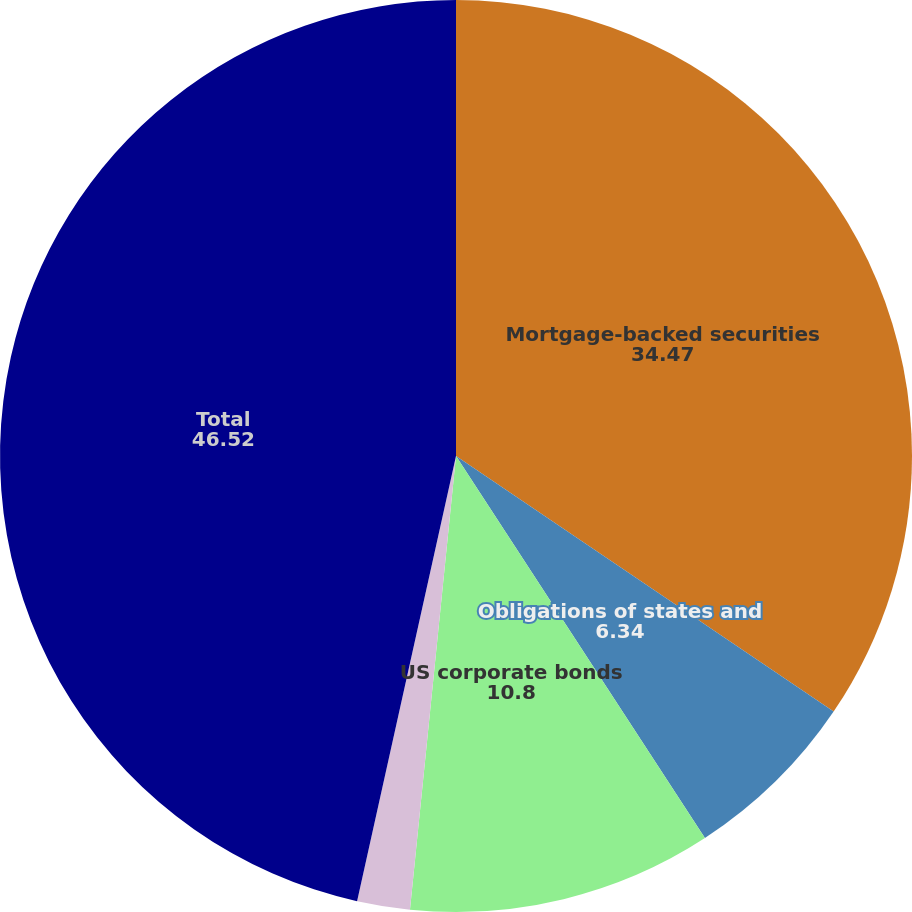Convert chart to OTSL. <chart><loc_0><loc_0><loc_500><loc_500><pie_chart><fcel>Mortgage-backed securities<fcel>Obligations of states and<fcel>US corporate bonds<fcel>Other<fcel>Total<nl><fcel>34.47%<fcel>6.34%<fcel>10.8%<fcel>1.87%<fcel>46.52%<nl></chart> 